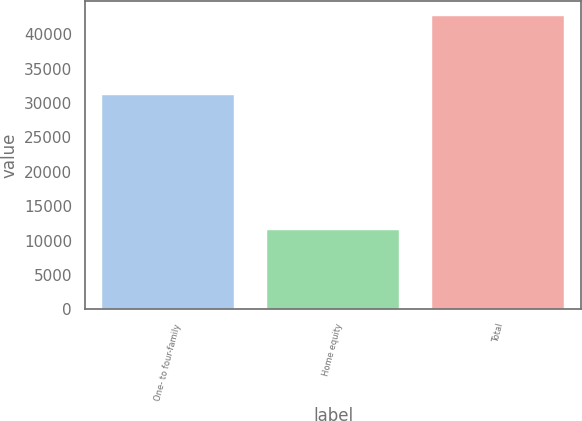Convert chart. <chart><loc_0><loc_0><loc_500><loc_500><bar_chart><fcel>One- to four-family<fcel>Home equity<fcel>Total<nl><fcel>31109<fcel>11559<fcel>42668<nl></chart> 